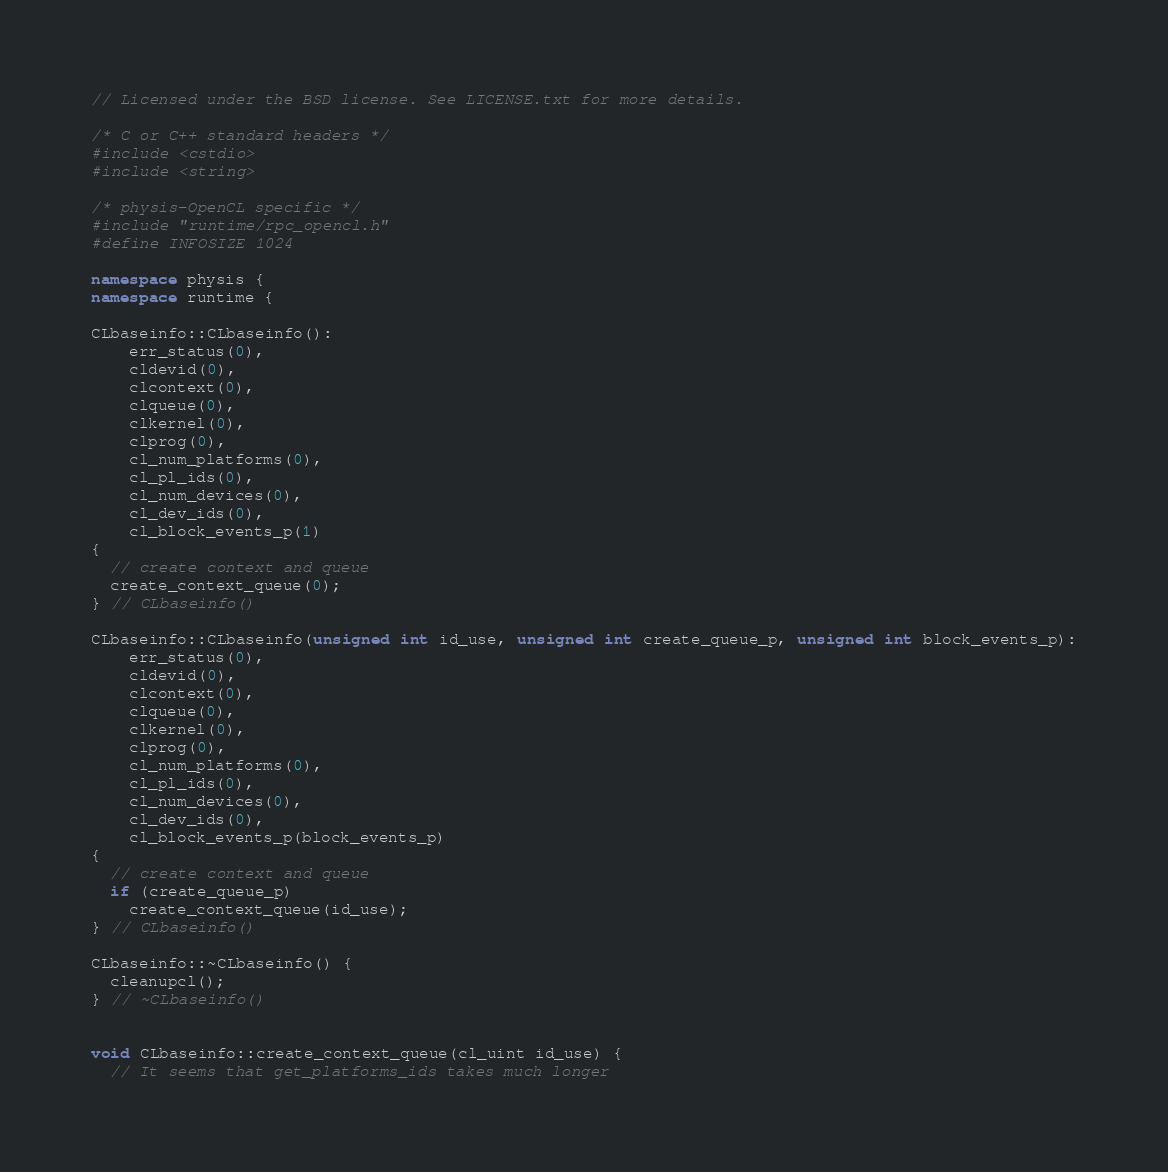<code> <loc_0><loc_0><loc_500><loc_500><_C++_>// Licensed under the BSD license. See LICENSE.txt for more details.

/* C or C++ standard headers */
#include <cstdio>
#include <string>

/* physis-OpenCL specific */
#include "runtime/rpc_opencl.h"
#define INFOSIZE 1024

namespace physis {
namespace runtime {

CLbaseinfo::CLbaseinfo():
    err_status(0),
    cldevid(0),
    clcontext(0),
    clqueue(0),
    clkernel(0),
    clprog(0),
    cl_num_platforms(0),
    cl_pl_ids(0),
    cl_num_devices(0),
    cl_dev_ids(0),
    cl_block_events_p(1)
{
  // create context and queue
  create_context_queue(0);
} // CLbaseinfo()

CLbaseinfo::CLbaseinfo(unsigned int id_use, unsigned int create_queue_p, unsigned int block_events_p):
    err_status(0),
    cldevid(0),
    clcontext(0),
    clqueue(0),
    clkernel(0),
    clprog(0),
    cl_num_platforms(0),
    cl_pl_ids(0),
    cl_num_devices(0),
    cl_dev_ids(0),
    cl_block_events_p(block_events_p)
{
  // create context and queue
  if (create_queue_p) 
    create_context_queue(id_use);
} // CLbaseinfo()

CLbaseinfo::~CLbaseinfo() {
  cleanupcl();
} // ~CLbaseinfo()


void CLbaseinfo::create_context_queue(cl_uint id_use) {
  // It seems that get_platforms_ids takes much longer</code> 